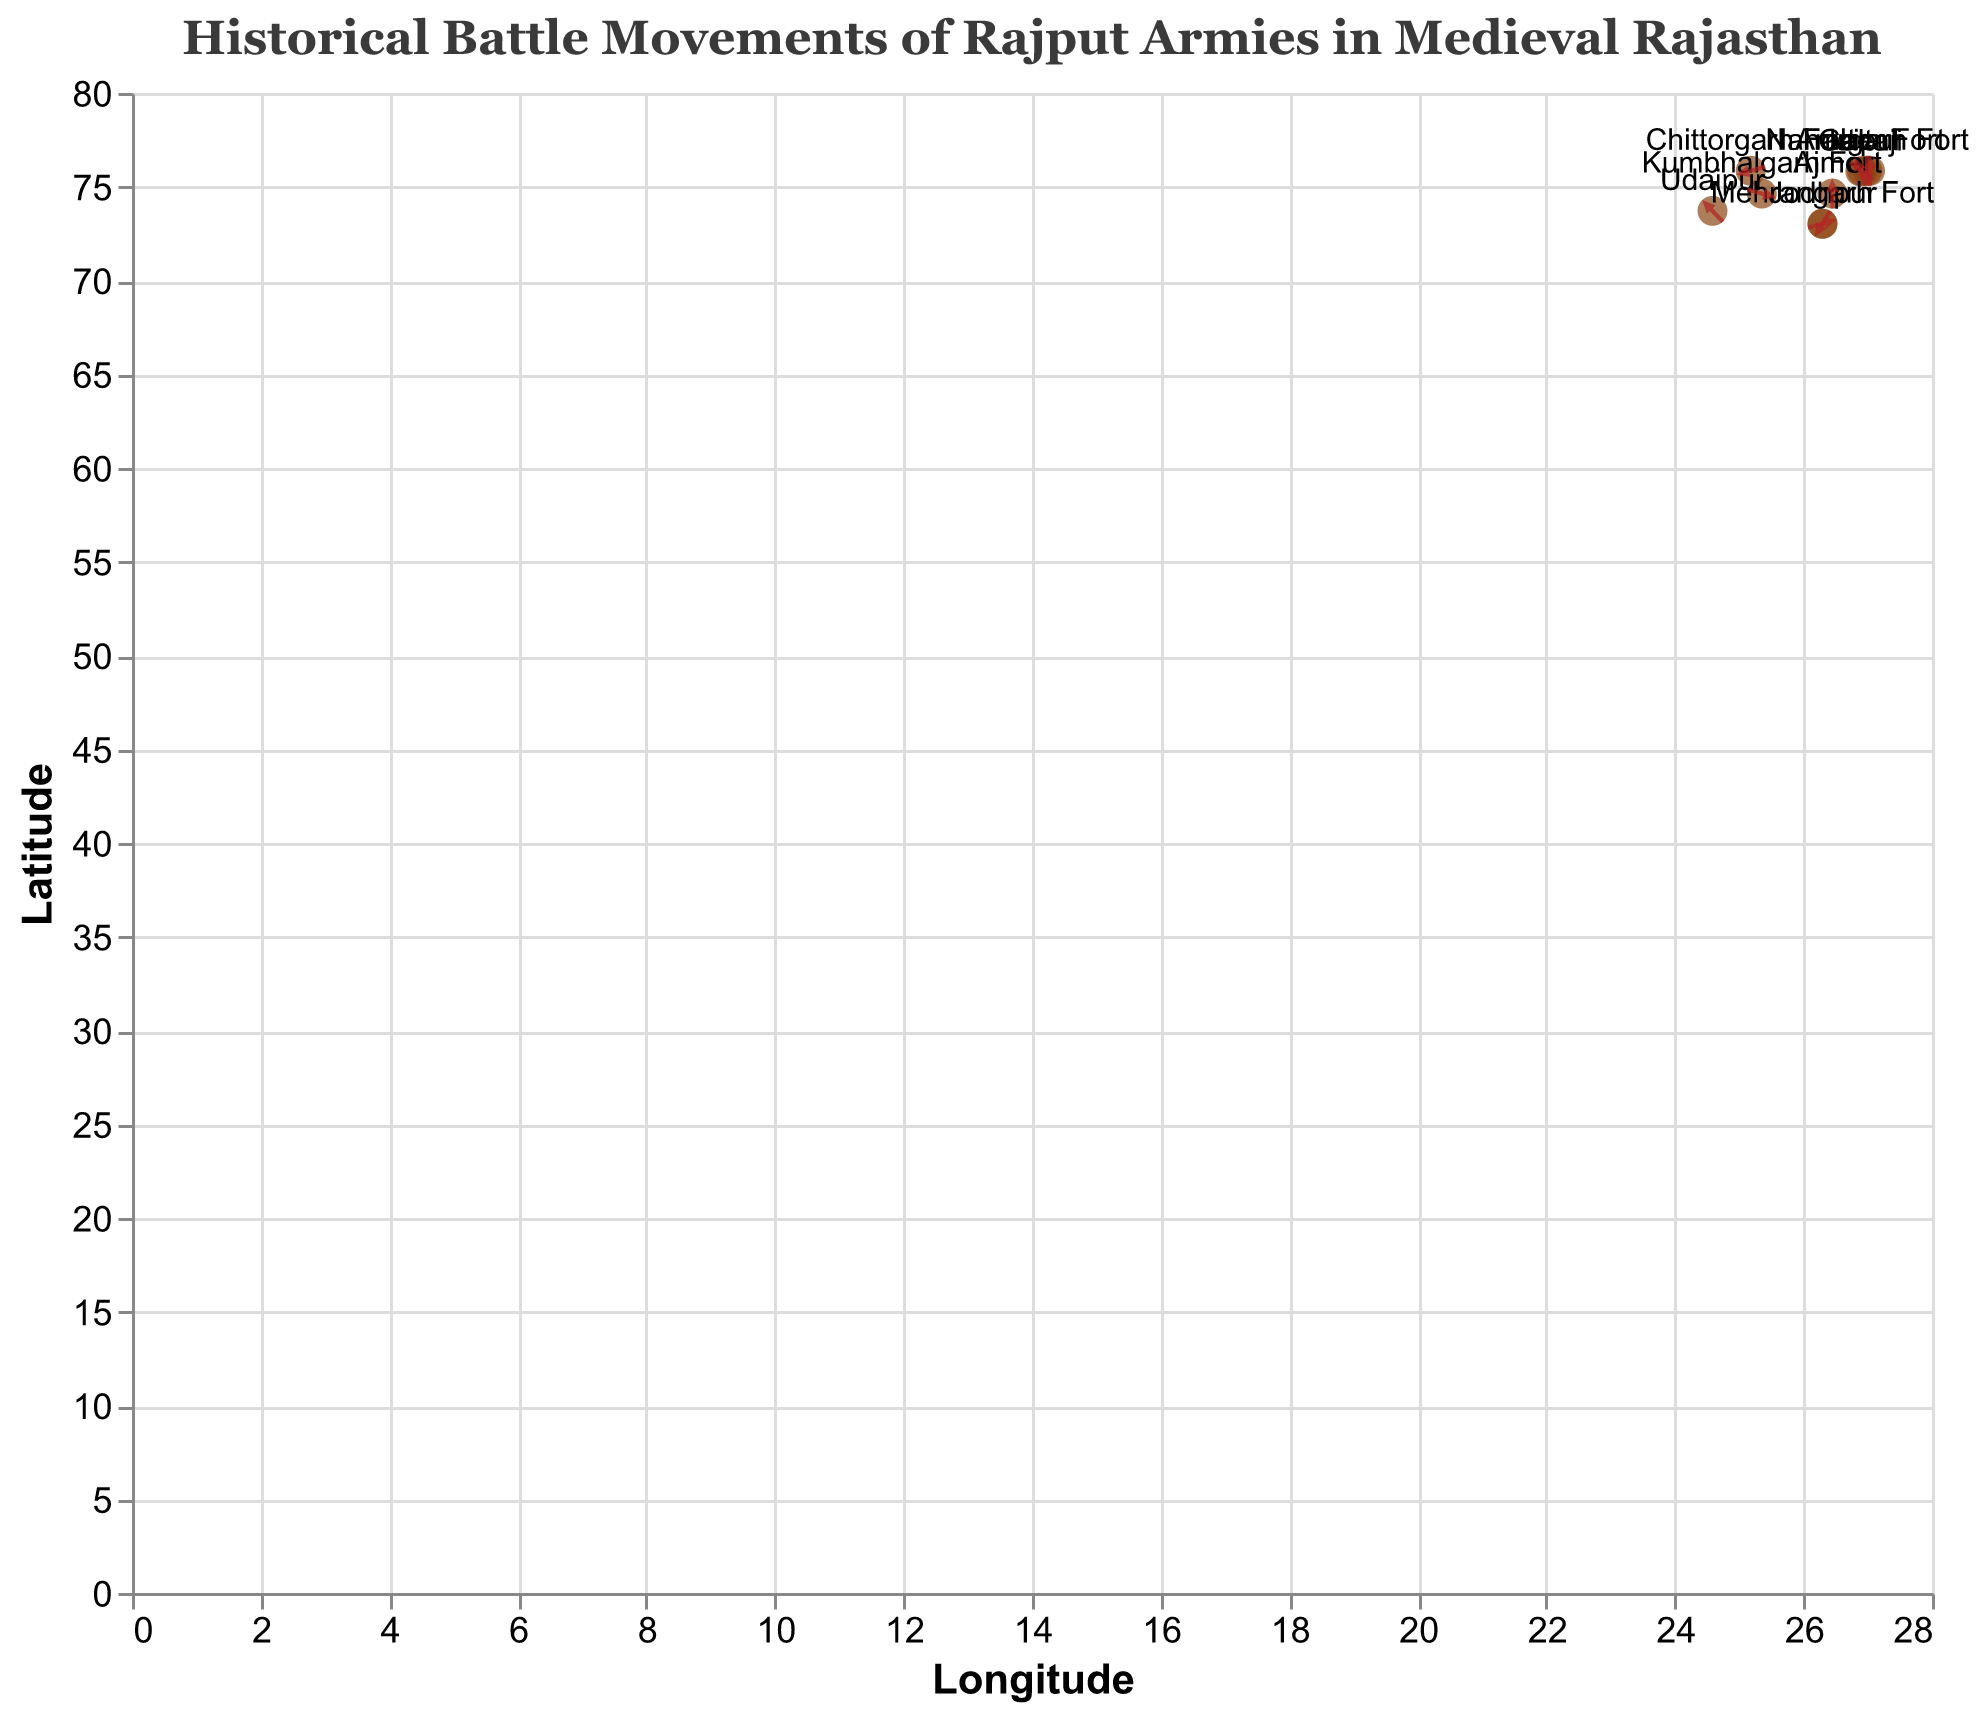What is the main title of the plot? The title is usually at the top of the plot and provides a summary of what the plot is depicting. Here, it states the main theme.
Answer: Historical Battle Movements of Rajput Armies in Medieval Rajasthan How many strategic locations (forts) are plotted on the figure? By counting the number of data points labeled with the names of locations, we can find the total number of strategic locations.
Answer: 10 Which fort has arrows pointing upwards only? The direction of arrows can be checked to see which one indicates upward movement.
Answer: Mehrangarh Fort Compare the movement direction of Amber Fort and Nahargarh Fort. Observing the direction of arrows from both locations, we see Amber Fort has arrows pointing southwest (-1,0.5), while Nahargarh has arrows pointing east (1,0).
Answer: Amber Fort: southwest; Nahargarh Fort: east Which location's movement is directed towards the southwest? By filtering the vectors that point towards the southwest direction (negative x and negative y), we find the corresponding location.
Answer: Ajmer Are the movements from Chittorgarh Fort and Udaipur similar? We analyze the direction vectors for both places to check their similarity. Chittorgarh has (0.5,1) and Udaipur has (-0.5,1). Since they are identical magnitudes but opposite x-direction, they can be considered.
Answer: No, the movements have opposite x-directions; Chittorgarh: (0.5,1), Udaipur: (-0.5,1) What is the average magnitude of movements shown in the figure? First, calculate the magnitude (sqrt(u² + v²)) for each point, then compute the average of these magnitudes: sqrt(1.25) for Amber, sqrt(0.5) for Jaipur, 1 for Mehrangarh, 1 for Nahargarh, sqrt(0.5) for Galtaji, 1.118 for Chittorgarh, sqrt(1.25) for Ajmer, sqrt(1.25) for Kumbhalgarh, sqrt(1.25) for Jodhpur, and 1.118 for Udaipur. Adding these and dividing by 10 gives us the mean.
Answer: √1.25, √0.5, 1, 1, √0.5, √1.25, √1.25, √1.25, √1.25, √1.25, Average ≈ 1.09 Which fort movements indicate a retreat, and in which direction? Retreats are often indicated by arrows pointing back to the origin, negative directions. We look for negative x and y vectors.
Answer: Amber Fort and Ajmer; Amber: southwest (-1,0.5), Ajmer: southwest (-1,-0.5) What is the furthest movement in latitude on the figure? Checking the 'v' values for the largest absolute value indicates furthest latitude movement. The largest absolute v value is 1 (Chittorgarh and Udaipur).
Answer: Chittorgarh and Udaipur Find a pair of forts that have opposite movement directions. Opposite movements will have opposite signs in their u and v values. By comparing such pairs: Amber (-1,0.5) and Jodhpur (1,0.5).
Answer: Amber Fort and Jodhpur 